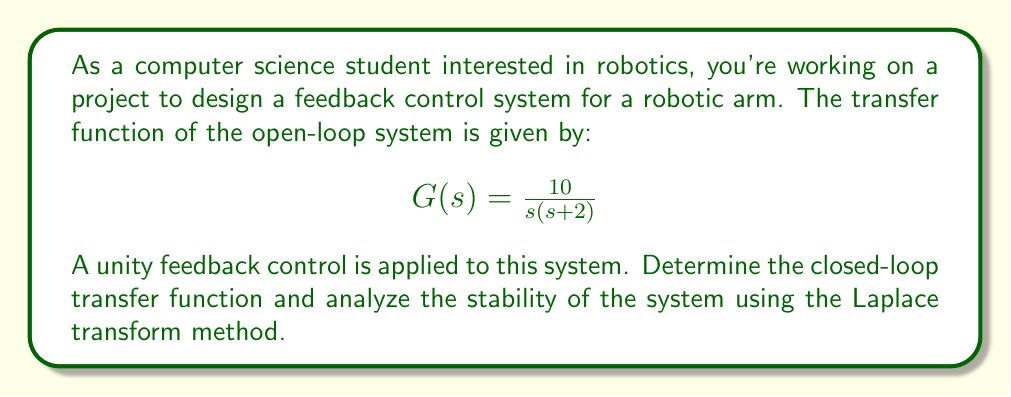Give your solution to this math problem. To solve this problem, we'll follow these steps:

1) First, let's recall the general form of a closed-loop transfer function with unity feedback:

   $$T(s) = \frac{G(s)}{1 + G(s)}$$

   where $G(s)$ is the open-loop transfer function.

2) Substitute the given $G(s)$ into this equation:

   $$T(s) = \frac{\frac{10}{s(s+2)}}{1 + \frac{10}{s(s+2)}}$$

3) To simplify this, let's find a common denominator:

   $$T(s) = \frac{10}{s(s+2) + 10}$$

4) Expand the denominator:

   $$T(s) = \frac{10}{s^2 + 2s + 10}$$

5) This is our closed-loop transfer function. To analyze stability, we need to find the poles of this function. The poles are the roots of the characteristic equation, which is the denominator set to zero:

   $$s^2 + 2s + 10 = 0$$

6) This is a quadratic equation. We can solve it using the quadratic formula:

   $$s = \frac{-b \pm \sqrt{b^2 - 4ac}}{2a}$$

   where $a=1$, $b=2$, and $c=10$

7) Substituting these values:

   $$s = \frac{-2 \pm \sqrt{2^2 - 4(1)(10)}}{2(1)} = \frac{-2 \pm \sqrt{4 - 40}}{2} = \frac{-2 \pm \sqrt{-36}}{2}$$

8) Simplify:

   $$s = -1 \pm i3$$

9) The poles are complex conjugates with negative real parts. In a control system, poles with negative real parts indicate stability. The imaginary parts indicate that the system will have oscillatory behavior, but the negative real parts ensure that these oscillations will decay over time.
Answer: The closed-loop transfer function is:

$$T(s) = \frac{10}{s^2 + 2s + 10}$$

The system is stable because the poles of the closed-loop transfer function ($s = -1 \pm i3$) have negative real parts. 